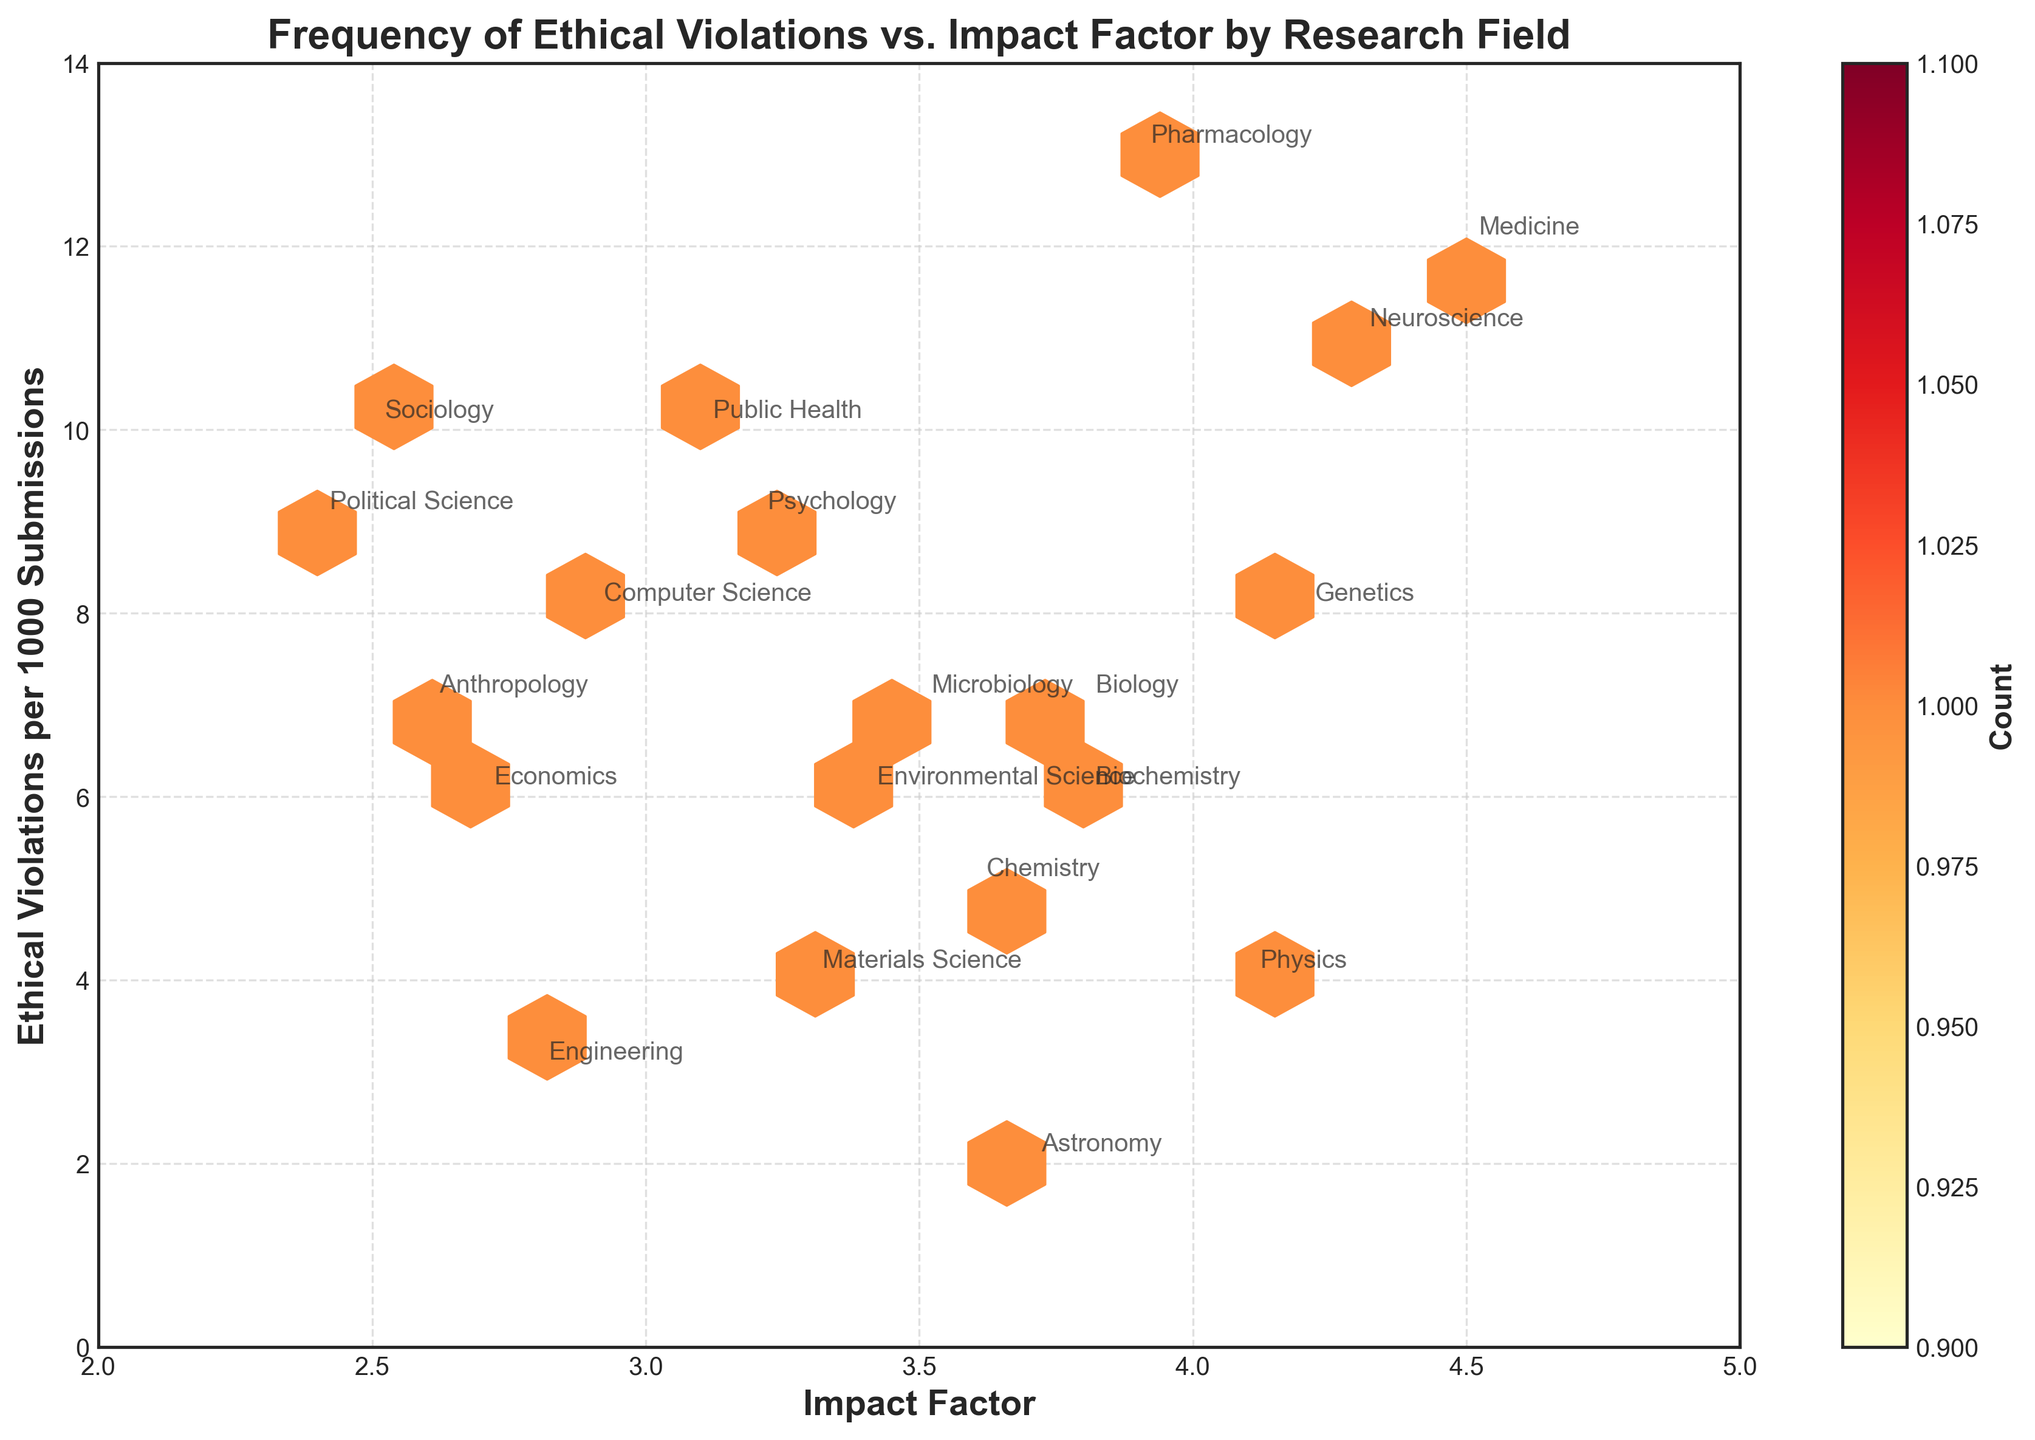What does the title of the figure indicate? The title "Frequency of Ethical Violations vs. Impact Factor by Research Field" indicates that the figure shows the relationship between the frequency of ethical violations in submitted manuscripts and their impact factors, categorized by research fields.
Answer: The relationship between ethical violations and impact factors by research field What are the axes labels in this figure? The x-axis is labeled "Impact Factor" and the y-axis is labeled "Ethical Violations per 1000 Submissions."
Answer: Impact Factor, Ethical Violations per 1000 Submissions What is the color of the hexagons used to represent the data? The hexagons are colored using a gradient from yellow to red, with 'YlOrRd' color map, where yellow indicates lower counts and red indicates higher counts.
Answer: Yellow to Red How many hexagons represent a count greater than 1? The color-bar shows the range, and the hexagons are drawn with different shades indicating counts. By looking at the color representation, all the hexagons shown have a count since the minimum count is set to 1.
Answer: All hexagons Which research field has the highest frequency of ethical violations per 1000 submissions? The field of Pharmacology has the highest frequency of ethical violations, marked at 13 violations per 1000 submissions.
Answer: Pharmacology Which research field has the lowest impact factor? The fields of Political Science and Sociology both have the lowest impact factor of 2.4 and 2.5 respectively.
Answer: Political Science and Sociology Which research fields have more than 10 ethical violations per 1000 submissions? The research fields with more than 10 ethical violations per 1000 submissions are Medicine (12), Neuroscience (11), and Pharmacology (13).
Answer: Medicine, Neuroscience, Pharmacology How many research fields have an impact factor equal to or greater than 4.0? By examining the x-axis and the annotations, Medicine, Physics, Neuroscience, and Genetics fields have impact factors equal to or greater than 4.0.
Answer: Four research fields Which research fields lie within the hexagon denoting the highest count of data points in the plot? The hexagon with the highest count can be identified by its color intensity. Research fields like Anthropology, Economics, and Microbiology seem to lie within or near the densest region.
Answer: Anthropology, Economics, Microbiology Is there a noticeable trend between impact factor and frequency of ethical violations? By observing the overall scatter of points within the hexbin plot, there doesn't seem to be a clear linear trend, as the data points are spread out without a strong correlation between impact factor and ethical violations.
Answer: No noticeable trend 